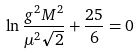Convert formula to latex. <formula><loc_0><loc_0><loc_500><loc_500>\ln \frac { g ^ { 2 } M ^ { 2 } } { \mu ^ { 2 } \sqrt { 2 } } + \frac { 2 5 } { 6 } = 0</formula> 